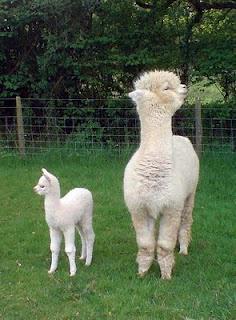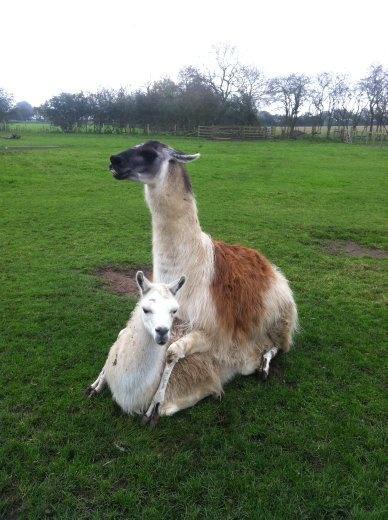The first image is the image on the left, the second image is the image on the right. Considering the images on both sides, is "The left image shows a small white llama standing alongside a taller white llama, both with bodies facing forward." valid? Answer yes or no. Yes. The first image is the image on the left, the second image is the image on the right. Evaluate the accuracy of this statement regarding the images: "The llamas in the left image are looking in opposite directions.". Is it true? Answer yes or no. Yes. 